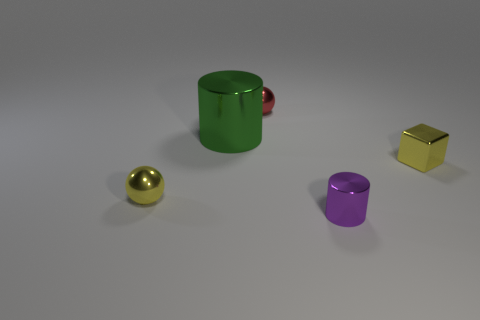Subtract all red cylinders. Subtract all yellow cubes. How many cylinders are left? 2 Add 5 big things. How many objects exist? 10 Subtract all cylinders. How many objects are left? 3 Add 4 cyan shiny things. How many cyan shiny things exist? 4 Subtract 1 green cylinders. How many objects are left? 4 Subtract all small blue objects. Subtract all purple shiny things. How many objects are left? 4 Add 4 tiny red metal spheres. How many tiny red metal spheres are left? 5 